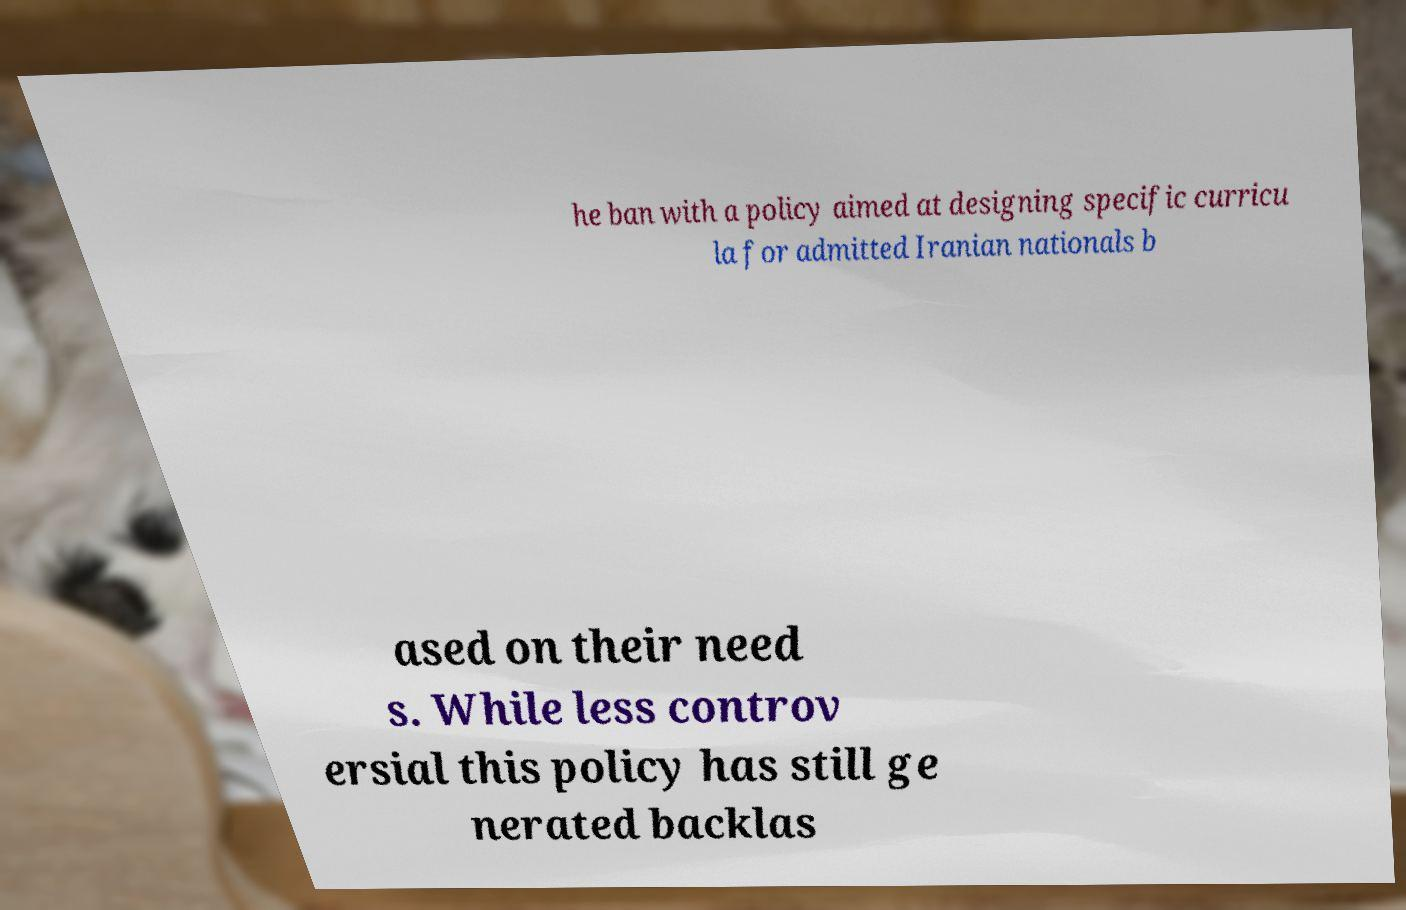Could you extract and type out the text from this image? he ban with a policy aimed at designing specific curricu la for admitted Iranian nationals b ased on their need s. While less controv ersial this policy has still ge nerated backlas 